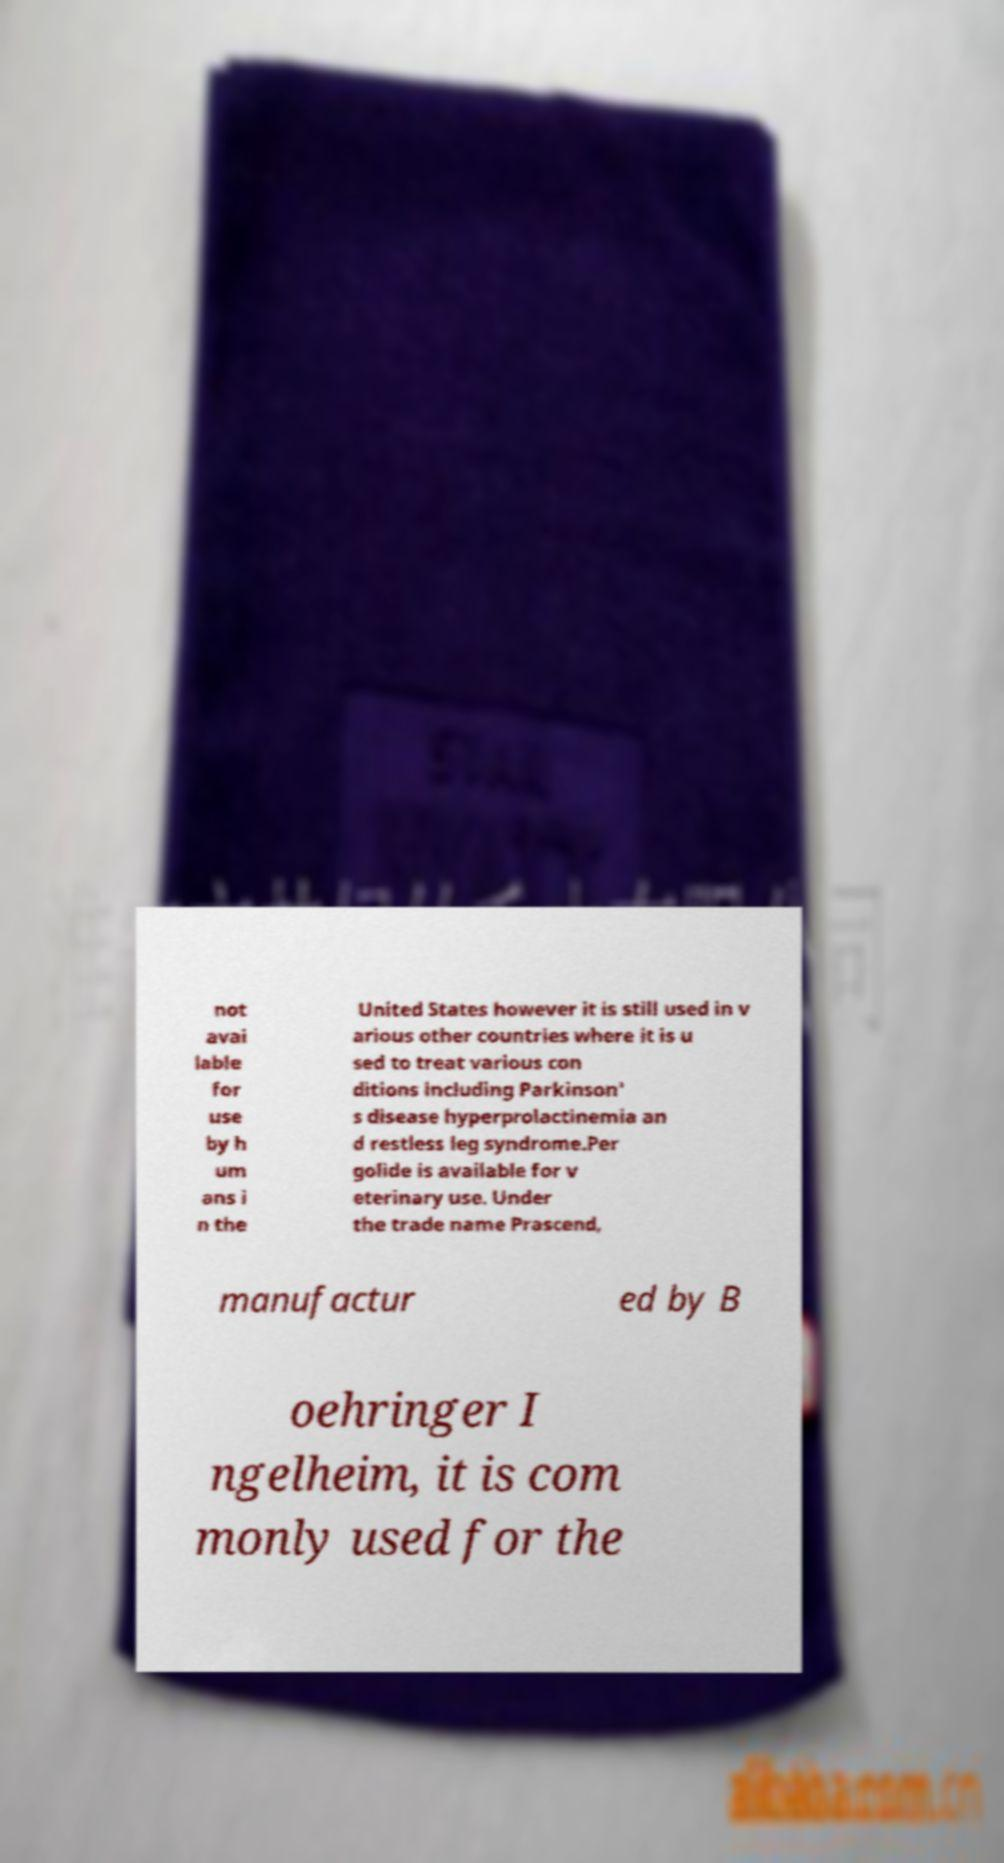What messages or text are displayed in this image? I need them in a readable, typed format. not avai lable for use by h um ans i n the United States however it is still used in v arious other countries where it is u sed to treat various con ditions including Parkinson' s disease hyperprolactinemia an d restless leg syndrome.Per golide is available for v eterinary use. Under the trade name Prascend, manufactur ed by B oehringer I ngelheim, it is com monly used for the 